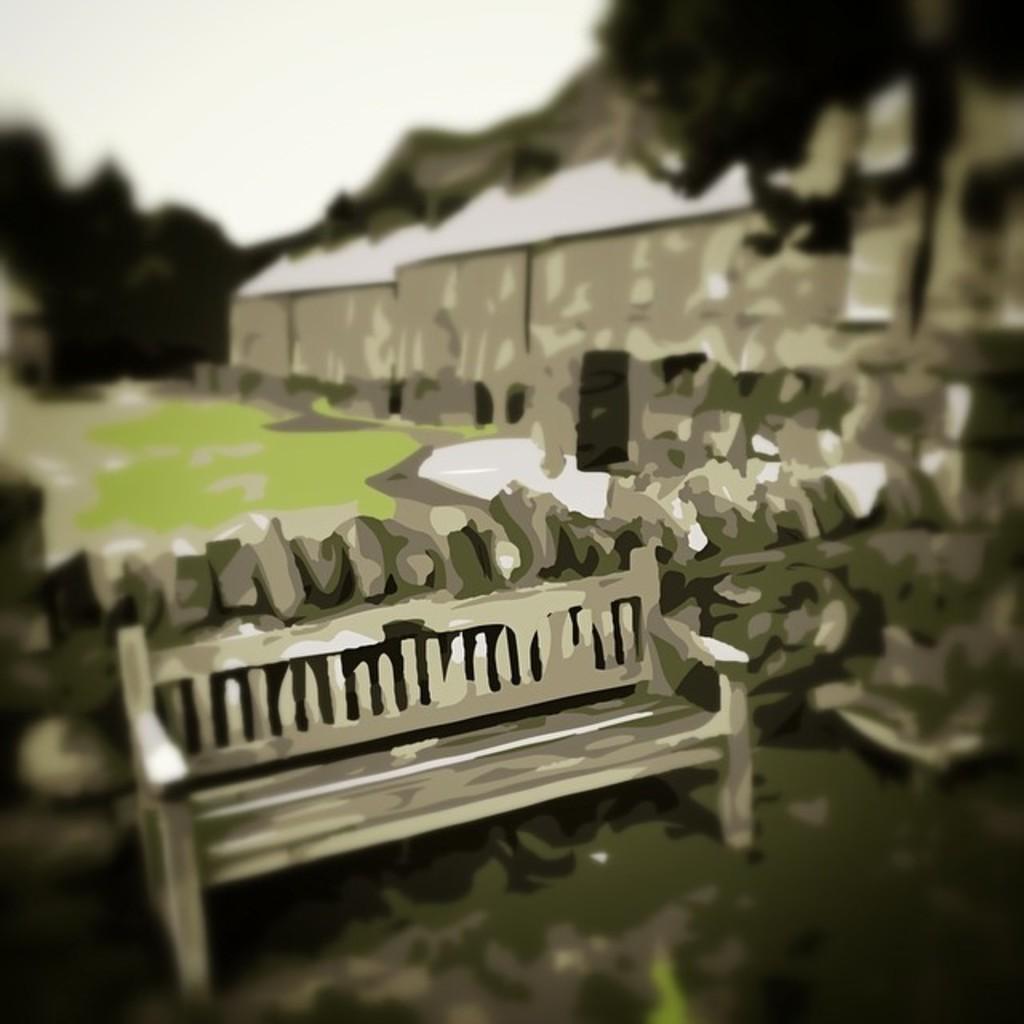Describe this image in one or two sentences. This looks like an animated image. This is the wooden bench. Here is the wall. This is the grass. I think these are the trees and houses. 